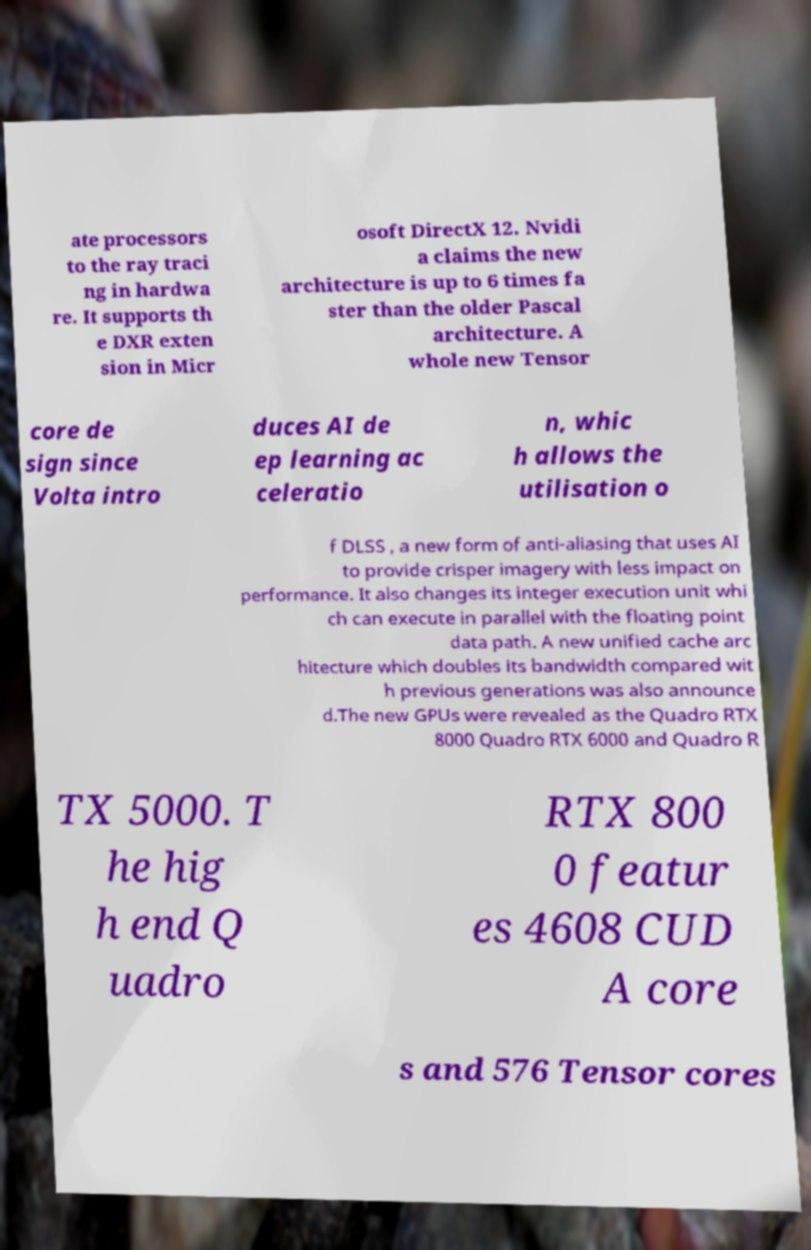Could you extract and type out the text from this image? ate processors to the ray traci ng in hardwa re. It supports th e DXR exten sion in Micr osoft DirectX 12. Nvidi a claims the new architecture is up to 6 times fa ster than the older Pascal architecture. A whole new Tensor core de sign since Volta intro duces AI de ep learning ac celeratio n, whic h allows the utilisation o f DLSS , a new form of anti-aliasing that uses AI to provide crisper imagery with less impact on performance. It also changes its integer execution unit whi ch can execute in parallel with the floating point data path. A new unified cache arc hitecture which doubles its bandwidth compared wit h previous generations was also announce d.The new GPUs were revealed as the Quadro RTX 8000 Quadro RTX 6000 and Quadro R TX 5000. T he hig h end Q uadro RTX 800 0 featur es 4608 CUD A core s and 576 Tensor cores 